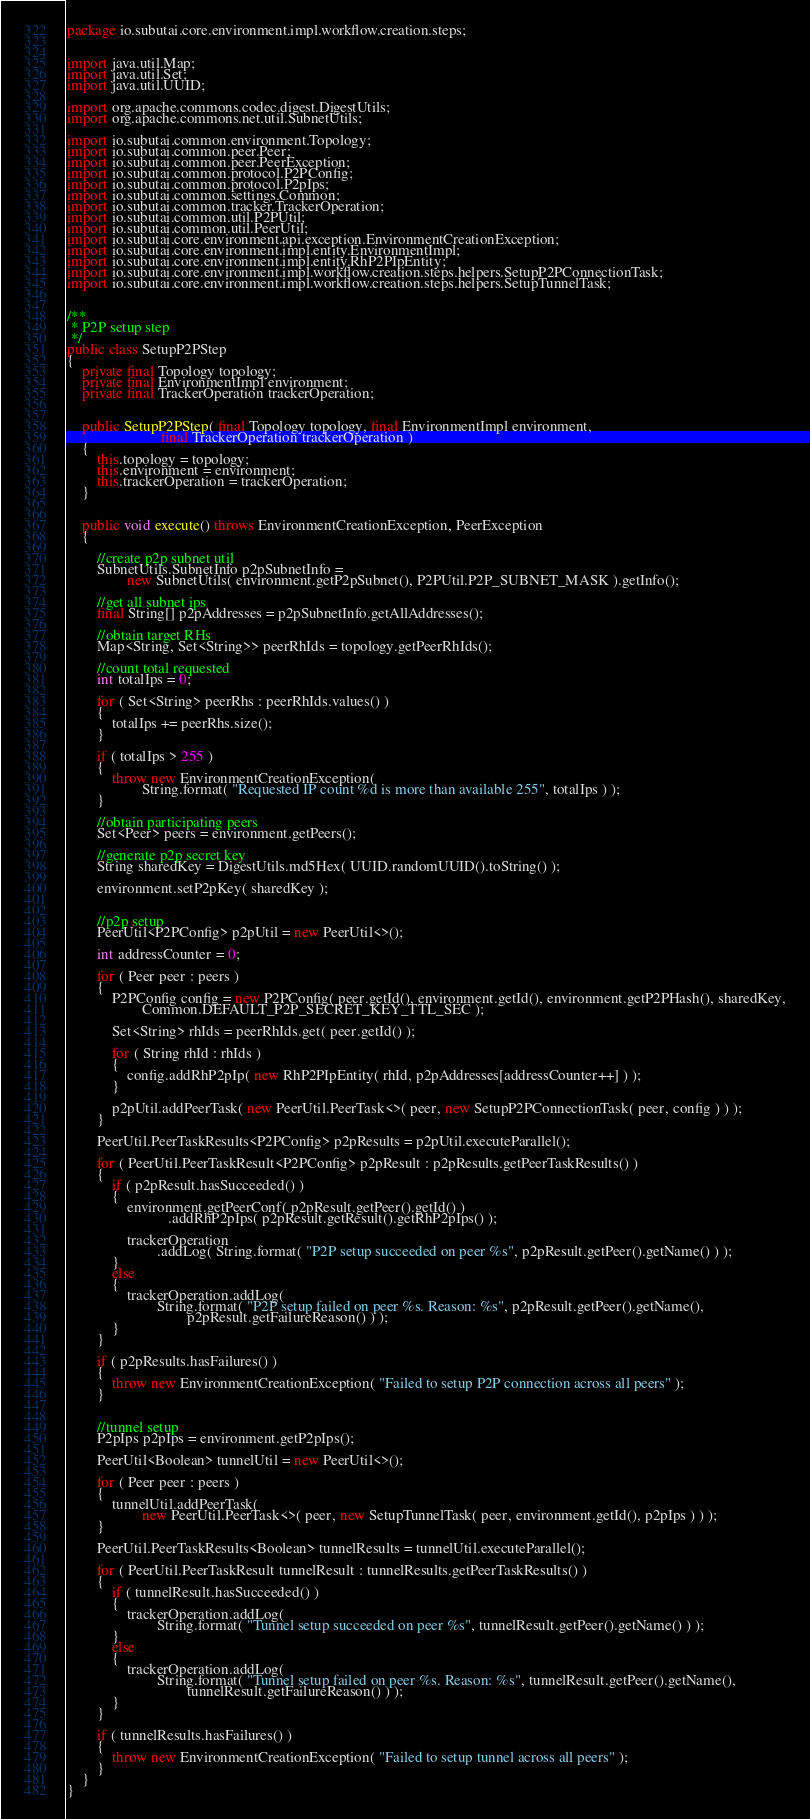Convert code to text. <code><loc_0><loc_0><loc_500><loc_500><_Java_>package io.subutai.core.environment.impl.workflow.creation.steps;


import java.util.Map;
import java.util.Set;
import java.util.UUID;

import org.apache.commons.codec.digest.DigestUtils;
import org.apache.commons.net.util.SubnetUtils;

import io.subutai.common.environment.Topology;
import io.subutai.common.peer.Peer;
import io.subutai.common.peer.PeerException;
import io.subutai.common.protocol.P2PConfig;
import io.subutai.common.protocol.P2pIps;
import io.subutai.common.settings.Common;
import io.subutai.common.tracker.TrackerOperation;
import io.subutai.common.util.P2PUtil;
import io.subutai.common.util.PeerUtil;
import io.subutai.core.environment.api.exception.EnvironmentCreationException;
import io.subutai.core.environment.impl.entity.EnvironmentImpl;
import io.subutai.core.environment.impl.entity.RhP2PIpEntity;
import io.subutai.core.environment.impl.workflow.creation.steps.helpers.SetupP2PConnectionTask;
import io.subutai.core.environment.impl.workflow.creation.steps.helpers.SetupTunnelTask;


/**
 * P2P setup step
 */
public class SetupP2PStep
{
    private final Topology topology;
    private final EnvironmentImpl environment;
    private final TrackerOperation trackerOperation;


    public SetupP2PStep( final Topology topology, final EnvironmentImpl environment,
                         final TrackerOperation trackerOperation )
    {
        this.topology = topology;
        this.environment = environment;
        this.trackerOperation = trackerOperation;
    }


    public void execute() throws EnvironmentCreationException, PeerException
    {

        //create p2p subnet util
        SubnetUtils.SubnetInfo p2pSubnetInfo =
                new SubnetUtils( environment.getP2pSubnet(), P2PUtil.P2P_SUBNET_MASK ).getInfo();

        //get all subnet ips
        final String[] p2pAddresses = p2pSubnetInfo.getAllAddresses();

        //obtain target RHs
        Map<String, Set<String>> peerRhIds = topology.getPeerRhIds();

        //count total requested
        int totalIps = 0;

        for ( Set<String> peerRhs : peerRhIds.values() )
        {
            totalIps += peerRhs.size();
        }

        if ( totalIps > 255 )
        {
            throw new EnvironmentCreationException(
                    String.format( "Requested IP count %d is more than available 255", totalIps ) );
        }

        //obtain participating peers
        Set<Peer> peers = environment.getPeers();

        //generate p2p secret key
        String sharedKey = DigestUtils.md5Hex( UUID.randomUUID().toString() );

        environment.setP2pKey( sharedKey );


        //p2p setup
        PeerUtil<P2PConfig> p2pUtil = new PeerUtil<>();

        int addressCounter = 0;

        for ( Peer peer : peers )
        {
            P2PConfig config = new P2PConfig( peer.getId(), environment.getId(), environment.getP2PHash(), sharedKey,
                    Common.DEFAULT_P2P_SECRET_KEY_TTL_SEC );

            Set<String> rhIds = peerRhIds.get( peer.getId() );

            for ( String rhId : rhIds )
            {
                config.addRhP2pIp( new RhP2PIpEntity( rhId, p2pAddresses[addressCounter++] ) );
            }

            p2pUtil.addPeerTask( new PeerUtil.PeerTask<>( peer, new SetupP2PConnectionTask( peer, config ) ) );
        }

        PeerUtil.PeerTaskResults<P2PConfig> p2pResults = p2pUtil.executeParallel();

        for ( PeerUtil.PeerTaskResult<P2PConfig> p2pResult : p2pResults.getPeerTaskResults() )
        {
            if ( p2pResult.hasSucceeded() )
            {
                environment.getPeerConf( p2pResult.getPeer().getId() )
                           .addRhP2pIps( p2pResult.getResult().getRhP2pIps() );

                trackerOperation
                        .addLog( String.format( "P2P setup succeeded on peer %s", p2pResult.getPeer().getName() ) );
            }
            else
            {
                trackerOperation.addLog(
                        String.format( "P2P setup failed on peer %s. Reason: %s", p2pResult.getPeer().getName(),
                                p2pResult.getFailureReason() ) );
            }
        }

        if ( p2pResults.hasFailures() )
        {
            throw new EnvironmentCreationException( "Failed to setup P2P connection across all peers" );
        }


        //tunnel setup
        P2pIps p2pIps = environment.getP2pIps();

        PeerUtil<Boolean> tunnelUtil = new PeerUtil<>();

        for ( Peer peer : peers )
        {
            tunnelUtil.addPeerTask(
                    new PeerUtil.PeerTask<>( peer, new SetupTunnelTask( peer, environment.getId(), p2pIps ) ) );
        }

        PeerUtil.PeerTaskResults<Boolean> tunnelResults = tunnelUtil.executeParallel();

        for ( PeerUtil.PeerTaskResult tunnelResult : tunnelResults.getPeerTaskResults() )
        {
            if ( tunnelResult.hasSucceeded() )
            {
                trackerOperation.addLog(
                        String.format( "Tunnel setup succeeded on peer %s", tunnelResult.getPeer().getName() ) );
            }
            else
            {
                trackerOperation.addLog(
                        String.format( "Tunnel setup failed on peer %s. Reason: %s", tunnelResult.getPeer().getName(),
                                tunnelResult.getFailureReason() ) );
            }
        }

        if ( tunnelResults.hasFailures() )
        {
            throw new EnvironmentCreationException( "Failed to setup tunnel across all peers" );
        }
    }
}
</code> 